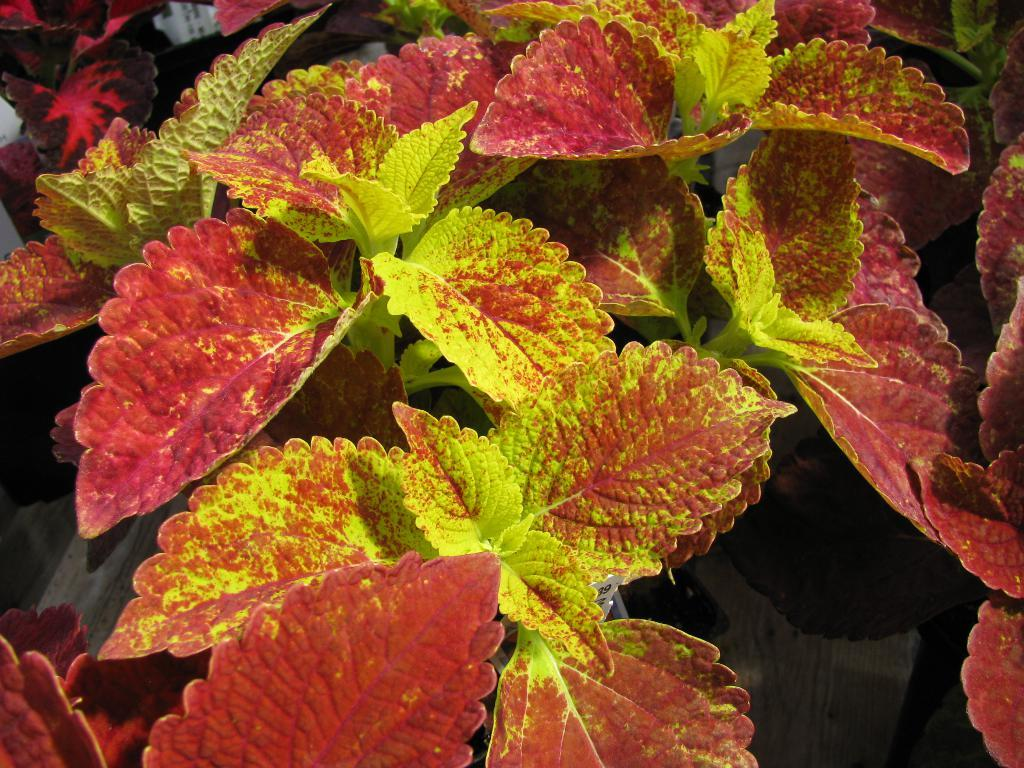What colors of leaves can be seen in the image? There are red and green color leaves in the image. Is there a hill in the image with a flag on top? There is no hill or flag present in the image; it only features leaves. 